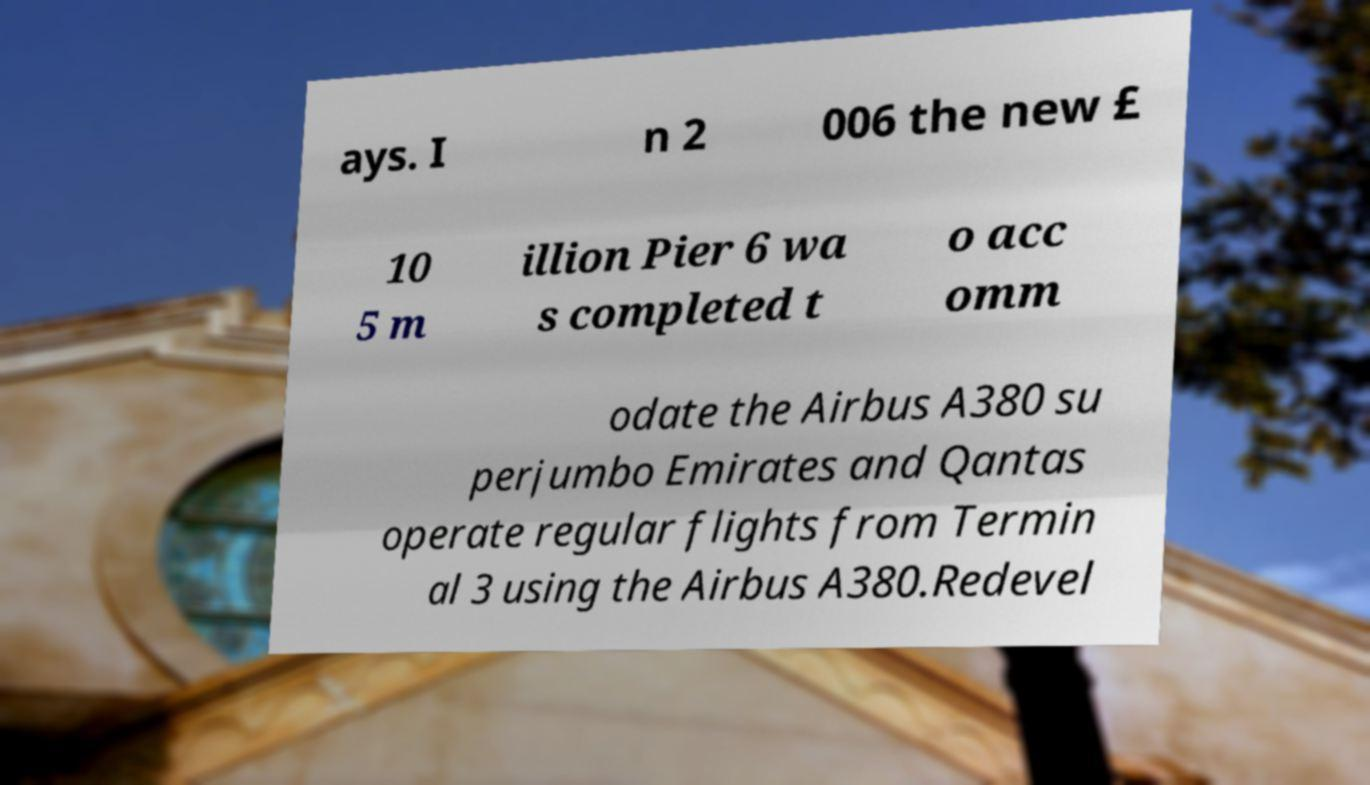What messages or text are displayed in this image? I need them in a readable, typed format. ays. I n 2 006 the new £ 10 5 m illion Pier 6 wa s completed t o acc omm odate the Airbus A380 su perjumbo Emirates and Qantas operate regular flights from Termin al 3 using the Airbus A380.Redevel 